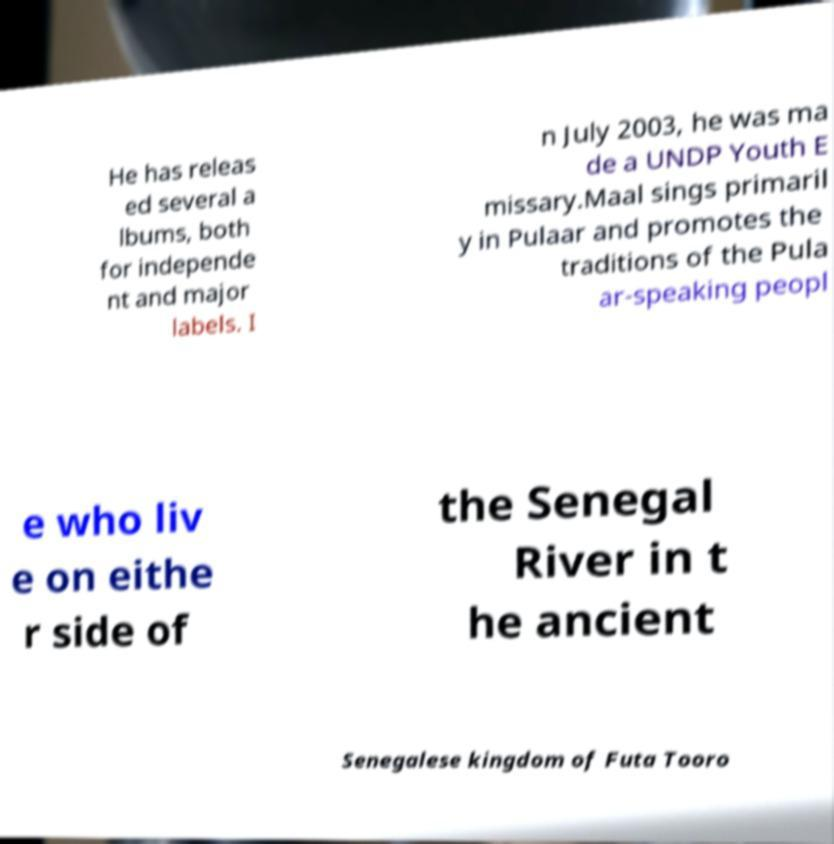Please identify and transcribe the text found in this image. He has releas ed several a lbums, both for independe nt and major labels. I n July 2003, he was ma de a UNDP Youth E missary.Maal sings primaril y in Pulaar and promotes the traditions of the Pula ar-speaking peopl e who liv e on eithe r side of the Senegal River in t he ancient Senegalese kingdom of Futa Tooro 